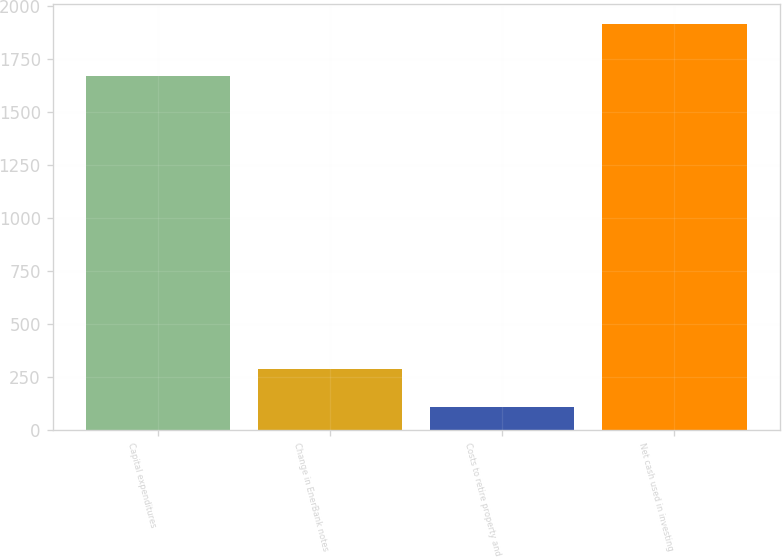Convert chart. <chart><loc_0><loc_0><loc_500><loc_500><bar_chart><fcel>Capital expenditures<fcel>Change in EnerBank notes<fcel>Costs to retire property and<fcel>Net cash used in investing<nl><fcel>1672<fcel>287.8<fcel>107<fcel>1915<nl></chart> 